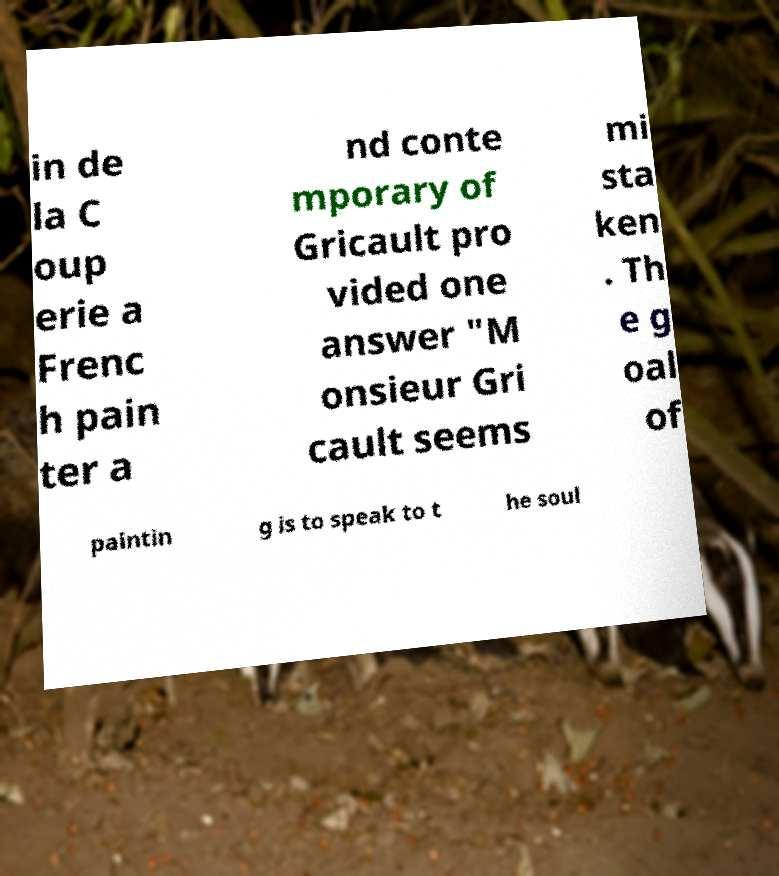For documentation purposes, I need the text within this image transcribed. Could you provide that? in de la C oup erie a Frenc h pain ter a nd conte mporary of Gricault pro vided one answer "M onsieur Gri cault seems mi sta ken . Th e g oal of paintin g is to speak to t he soul 